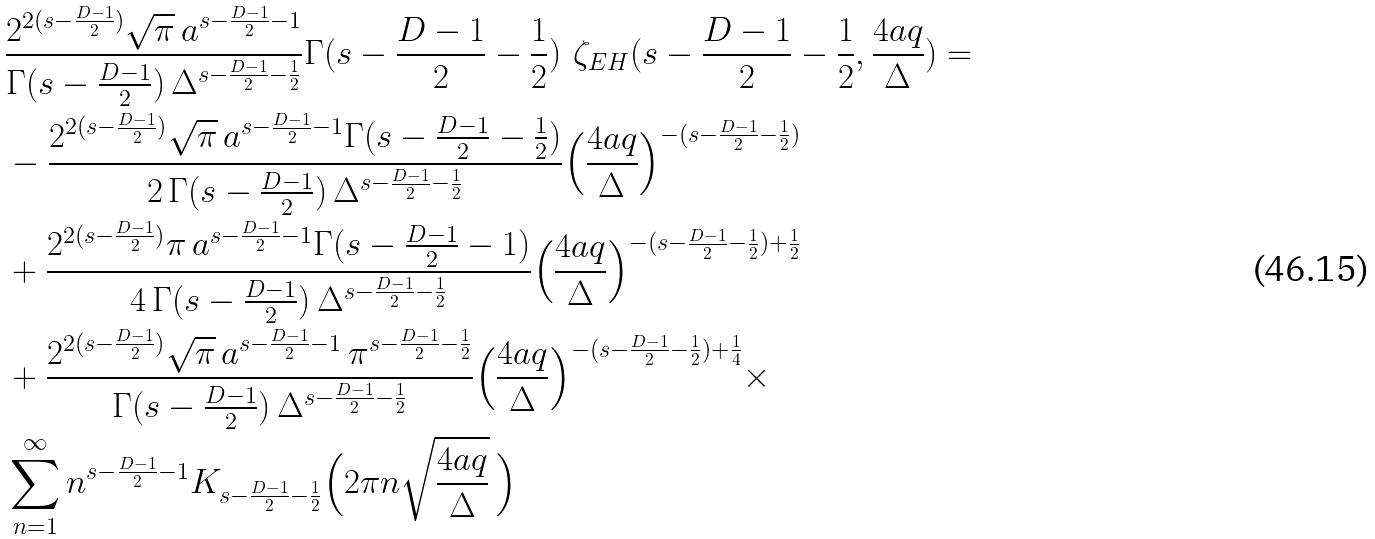<formula> <loc_0><loc_0><loc_500><loc_500>& \frac { 2 ^ { 2 ( s - \frac { D - 1 } { 2 } ) } \sqrt { \pi } { \, } a ^ { s - \frac { D - 1 } { 2 } - 1 } } { \Gamma ( s - \frac { D - 1 } { 2 } ) { \, } \Delta ^ { s - \frac { D - 1 } { 2 } - \frac { 1 } { 2 } } } \Gamma ( s - \frac { D - 1 } { 2 } - \frac { 1 } { 2 } ) { \, } { \, } \zeta _ { E H } ( s - \frac { D - 1 } { 2 } - \frac { 1 } { 2 } , \frac { 4 a q } { \Delta } ) = \\ & - \frac { 2 ^ { 2 ( s - \frac { D - 1 } { 2 } ) } \sqrt { \pi } { \, } a ^ { s - \frac { D - 1 } { 2 } - 1 } \Gamma ( s - \frac { D - 1 } { 2 } - \frac { 1 } { 2 } ) } { 2 { \, } \Gamma ( s - \frac { D - 1 } { 2 } ) { \, } \Delta ^ { s - \frac { D - 1 } { 2 } - \frac { 1 } { 2 } } } \Big { ( } \frac { 4 a q } { \Delta } \Big { ) } ^ { - ( s - \frac { D - 1 } { 2 } - \frac { 1 } { 2 } ) } \\ & + \frac { 2 ^ { 2 ( s - \frac { D - 1 } { 2 } ) } \pi { \, } a ^ { s - \frac { D - 1 } { 2 } - 1 } \Gamma ( s - \frac { D - 1 } { 2 } - 1 ) } { 4 { \, } \Gamma ( s - \frac { D - 1 } { 2 } ) { \, } \Delta ^ { s - \frac { D - 1 } { 2 } - \frac { 1 } { 2 } } } \Big { ( } \frac { 4 a q } { \Delta } \Big { ) } ^ { - ( s - \frac { D - 1 } { 2 } - \frac { 1 } { 2 } ) + \frac { 1 } { 2 } } \\ & + \frac { 2 ^ { 2 ( s - \frac { D - 1 } { 2 } ) } \sqrt { \pi } { \, } a ^ { s - \frac { D - 1 } { 2 } - 1 } { \, } \pi ^ { s - \frac { D - 1 } { 2 } - \frac { 1 } { 2 } } } { \Gamma ( s - \frac { D - 1 } { 2 } ) { \, } \Delta ^ { s - \frac { D - 1 } { 2 } - \frac { 1 } { 2 } } } \Big { ( } \frac { 4 a q } { \Delta } \Big { ) } ^ { - ( s - \frac { D - 1 } { 2 } - \frac { 1 } { 2 } ) + \frac { 1 } { 4 } } \times \\ & \sum _ { n = 1 } ^ { \infty } n ^ { s - \frac { D - 1 } { 2 } - 1 } K _ { s - \frac { D - 1 } { 2 } - \frac { 1 } { 2 } } \Big { ( } 2 \pi n \sqrt { \frac { 4 a q } { \Delta } } { \, } \Big { ) }</formula> 